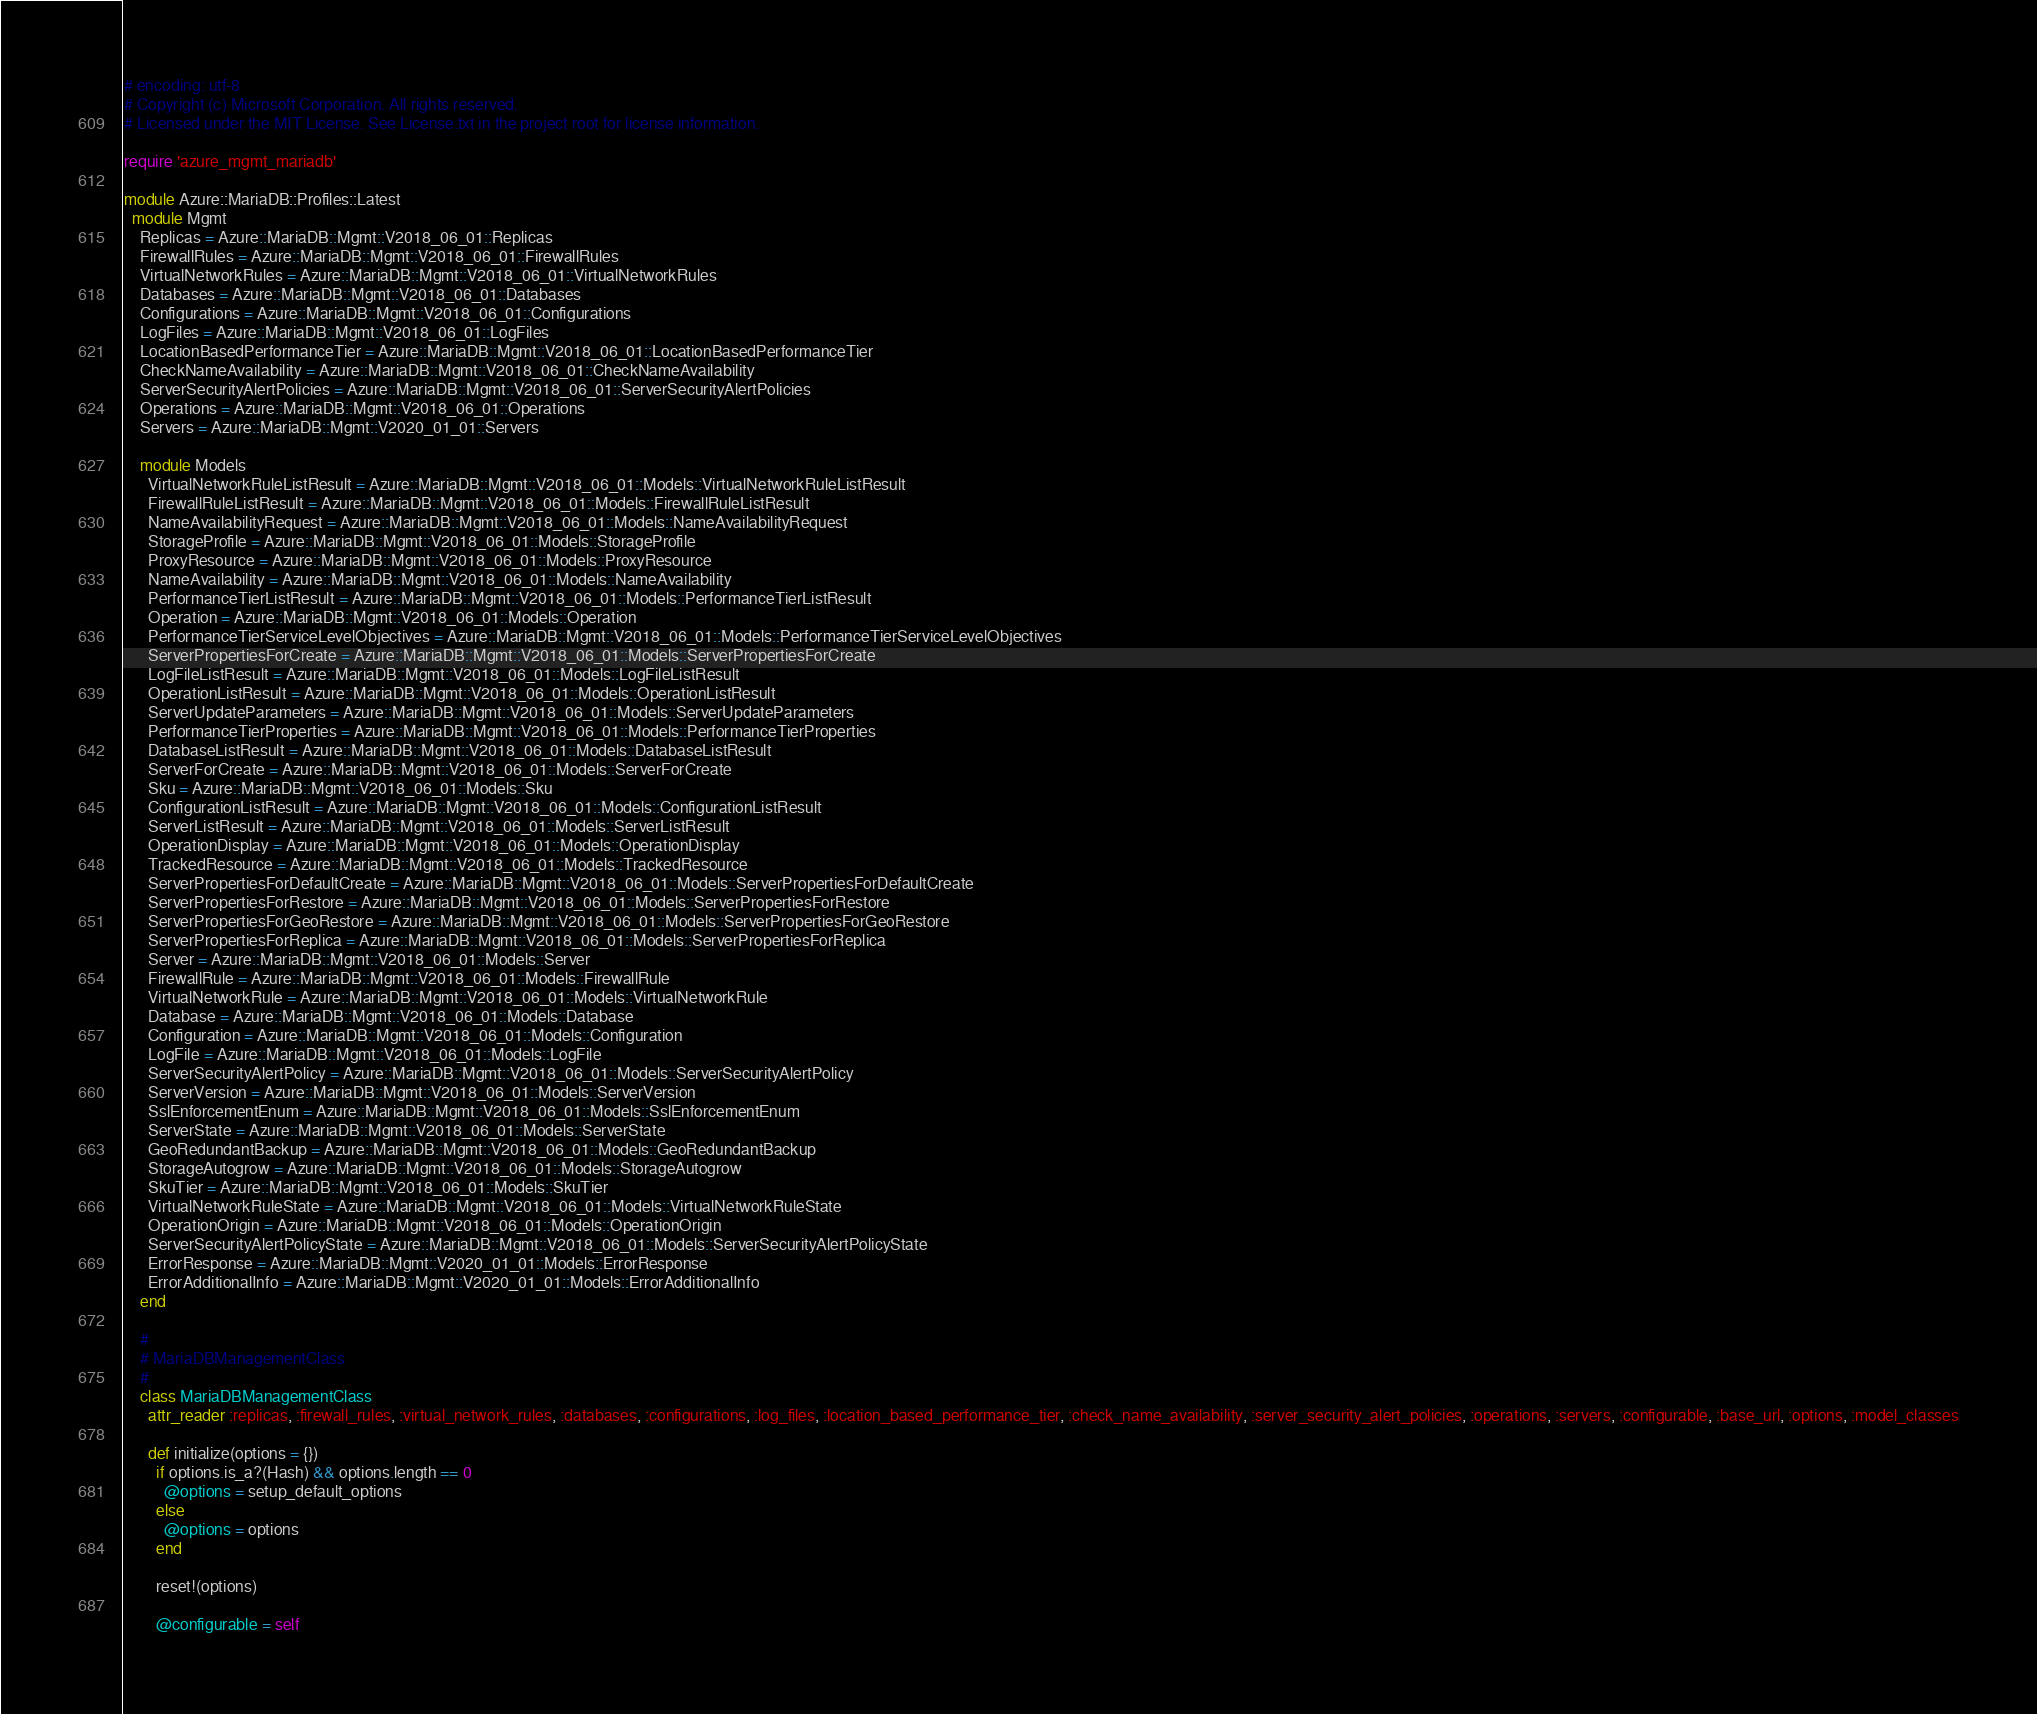<code> <loc_0><loc_0><loc_500><loc_500><_Ruby_># encoding: utf-8
# Copyright (c) Microsoft Corporation. All rights reserved.
# Licensed under the MIT License. See License.txt in the project root for license information.

require 'azure_mgmt_mariadb'

module Azure::MariaDB::Profiles::Latest
  module Mgmt
    Replicas = Azure::MariaDB::Mgmt::V2018_06_01::Replicas
    FirewallRules = Azure::MariaDB::Mgmt::V2018_06_01::FirewallRules
    VirtualNetworkRules = Azure::MariaDB::Mgmt::V2018_06_01::VirtualNetworkRules
    Databases = Azure::MariaDB::Mgmt::V2018_06_01::Databases
    Configurations = Azure::MariaDB::Mgmt::V2018_06_01::Configurations
    LogFiles = Azure::MariaDB::Mgmt::V2018_06_01::LogFiles
    LocationBasedPerformanceTier = Azure::MariaDB::Mgmt::V2018_06_01::LocationBasedPerformanceTier
    CheckNameAvailability = Azure::MariaDB::Mgmt::V2018_06_01::CheckNameAvailability
    ServerSecurityAlertPolicies = Azure::MariaDB::Mgmt::V2018_06_01::ServerSecurityAlertPolicies
    Operations = Azure::MariaDB::Mgmt::V2018_06_01::Operations
    Servers = Azure::MariaDB::Mgmt::V2020_01_01::Servers

    module Models
      VirtualNetworkRuleListResult = Azure::MariaDB::Mgmt::V2018_06_01::Models::VirtualNetworkRuleListResult
      FirewallRuleListResult = Azure::MariaDB::Mgmt::V2018_06_01::Models::FirewallRuleListResult
      NameAvailabilityRequest = Azure::MariaDB::Mgmt::V2018_06_01::Models::NameAvailabilityRequest
      StorageProfile = Azure::MariaDB::Mgmt::V2018_06_01::Models::StorageProfile
      ProxyResource = Azure::MariaDB::Mgmt::V2018_06_01::Models::ProxyResource
      NameAvailability = Azure::MariaDB::Mgmt::V2018_06_01::Models::NameAvailability
      PerformanceTierListResult = Azure::MariaDB::Mgmt::V2018_06_01::Models::PerformanceTierListResult
      Operation = Azure::MariaDB::Mgmt::V2018_06_01::Models::Operation
      PerformanceTierServiceLevelObjectives = Azure::MariaDB::Mgmt::V2018_06_01::Models::PerformanceTierServiceLevelObjectives
      ServerPropertiesForCreate = Azure::MariaDB::Mgmt::V2018_06_01::Models::ServerPropertiesForCreate
      LogFileListResult = Azure::MariaDB::Mgmt::V2018_06_01::Models::LogFileListResult
      OperationListResult = Azure::MariaDB::Mgmt::V2018_06_01::Models::OperationListResult
      ServerUpdateParameters = Azure::MariaDB::Mgmt::V2018_06_01::Models::ServerUpdateParameters
      PerformanceTierProperties = Azure::MariaDB::Mgmt::V2018_06_01::Models::PerformanceTierProperties
      DatabaseListResult = Azure::MariaDB::Mgmt::V2018_06_01::Models::DatabaseListResult
      ServerForCreate = Azure::MariaDB::Mgmt::V2018_06_01::Models::ServerForCreate
      Sku = Azure::MariaDB::Mgmt::V2018_06_01::Models::Sku
      ConfigurationListResult = Azure::MariaDB::Mgmt::V2018_06_01::Models::ConfigurationListResult
      ServerListResult = Azure::MariaDB::Mgmt::V2018_06_01::Models::ServerListResult
      OperationDisplay = Azure::MariaDB::Mgmt::V2018_06_01::Models::OperationDisplay
      TrackedResource = Azure::MariaDB::Mgmt::V2018_06_01::Models::TrackedResource
      ServerPropertiesForDefaultCreate = Azure::MariaDB::Mgmt::V2018_06_01::Models::ServerPropertiesForDefaultCreate
      ServerPropertiesForRestore = Azure::MariaDB::Mgmt::V2018_06_01::Models::ServerPropertiesForRestore
      ServerPropertiesForGeoRestore = Azure::MariaDB::Mgmt::V2018_06_01::Models::ServerPropertiesForGeoRestore
      ServerPropertiesForReplica = Azure::MariaDB::Mgmt::V2018_06_01::Models::ServerPropertiesForReplica
      Server = Azure::MariaDB::Mgmt::V2018_06_01::Models::Server
      FirewallRule = Azure::MariaDB::Mgmt::V2018_06_01::Models::FirewallRule
      VirtualNetworkRule = Azure::MariaDB::Mgmt::V2018_06_01::Models::VirtualNetworkRule
      Database = Azure::MariaDB::Mgmt::V2018_06_01::Models::Database
      Configuration = Azure::MariaDB::Mgmt::V2018_06_01::Models::Configuration
      LogFile = Azure::MariaDB::Mgmt::V2018_06_01::Models::LogFile
      ServerSecurityAlertPolicy = Azure::MariaDB::Mgmt::V2018_06_01::Models::ServerSecurityAlertPolicy
      ServerVersion = Azure::MariaDB::Mgmt::V2018_06_01::Models::ServerVersion
      SslEnforcementEnum = Azure::MariaDB::Mgmt::V2018_06_01::Models::SslEnforcementEnum
      ServerState = Azure::MariaDB::Mgmt::V2018_06_01::Models::ServerState
      GeoRedundantBackup = Azure::MariaDB::Mgmt::V2018_06_01::Models::GeoRedundantBackup
      StorageAutogrow = Azure::MariaDB::Mgmt::V2018_06_01::Models::StorageAutogrow
      SkuTier = Azure::MariaDB::Mgmt::V2018_06_01::Models::SkuTier
      VirtualNetworkRuleState = Azure::MariaDB::Mgmt::V2018_06_01::Models::VirtualNetworkRuleState
      OperationOrigin = Azure::MariaDB::Mgmt::V2018_06_01::Models::OperationOrigin
      ServerSecurityAlertPolicyState = Azure::MariaDB::Mgmt::V2018_06_01::Models::ServerSecurityAlertPolicyState
      ErrorResponse = Azure::MariaDB::Mgmt::V2020_01_01::Models::ErrorResponse
      ErrorAdditionalInfo = Azure::MariaDB::Mgmt::V2020_01_01::Models::ErrorAdditionalInfo
    end

    #
    # MariaDBManagementClass
    #
    class MariaDBManagementClass
      attr_reader :replicas, :firewall_rules, :virtual_network_rules, :databases, :configurations, :log_files, :location_based_performance_tier, :check_name_availability, :server_security_alert_policies, :operations, :servers, :configurable, :base_url, :options, :model_classes

      def initialize(options = {})
        if options.is_a?(Hash) && options.length == 0
          @options = setup_default_options
        else
          @options = options
        end

        reset!(options)

        @configurable = self</code> 